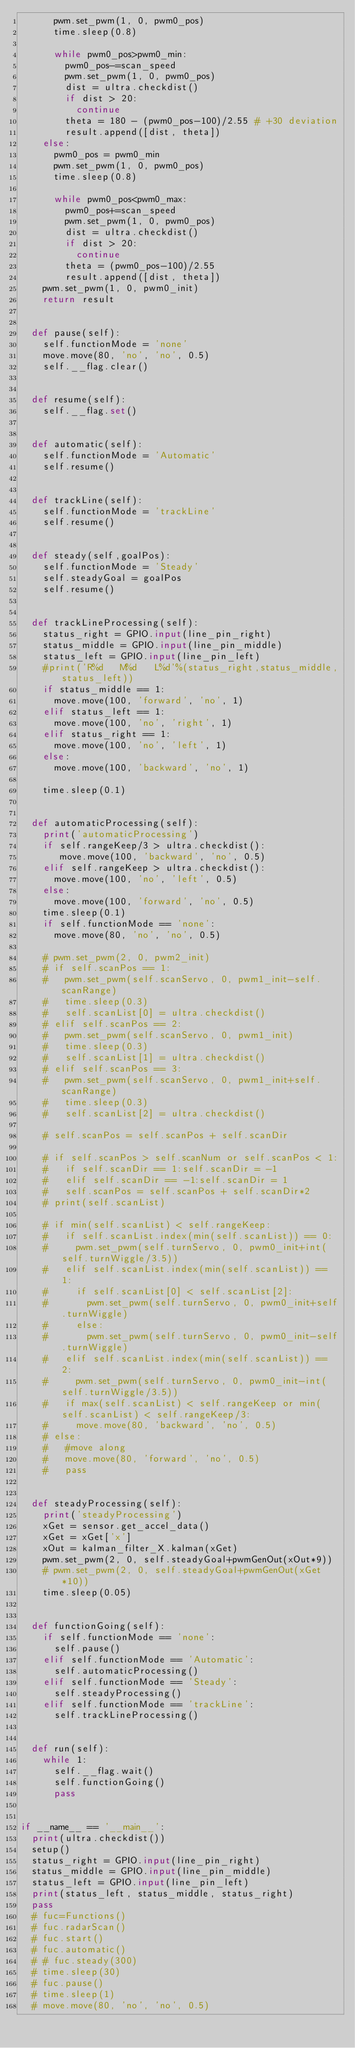<code> <loc_0><loc_0><loc_500><loc_500><_Python_>			pwm.set_pwm(1, 0, pwm0_pos)
			time.sleep(0.8)

			while pwm0_pos>pwm0_min:
				pwm0_pos-=scan_speed
				pwm.set_pwm(1, 0, pwm0_pos)
				dist = ultra.checkdist()
				if dist > 20:
					continue
				theta = 180 - (pwm0_pos-100)/2.55 # +30 deviation
				result.append([dist, theta])
		else:
			pwm0_pos = pwm0_min
			pwm.set_pwm(1, 0, pwm0_pos)
			time.sleep(0.8)

			while pwm0_pos<pwm0_max:
				pwm0_pos+=scan_speed
				pwm.set_pwm(1, 0, pwm0_pos)
				dist = ultra.checkdist()
				if dist > 20:
					continue
				theta = (pwm0_pos-100)/2.55
				result.append([dist, theta])
		pwm.set_pwm(1, 0, pwm0_init)
		return result


	def pause(self):
		self.functionMode = 'none'
		move.move(80, 'no', 'no', 0.5)
		self.__flag.clear()


	def resume(self):
		self.__flag.set()


	def automatic(self):
		self.functionMode = 'Automatic'
		self.resume()


	def trackLine(self):
		self.functionMode = 'trackLine'
		self.resume()


	def steady(self,goalPos):
		self.functionMode = 'Steady'
		self.steadyGoal = goalPos
		self.resume()


	def trackLineProcessing(self):
		status_right = GPIO.input(line_pin_right)
		status_middle = GPIO.input(line_pin_middle)
		status_left = GPIO.input(line_pin_left)
		#print('R%d   M%d   L%d'%(status_right,status_middle,status_left))
		if status_middle == 1:
			move.move(100, 'forward', 'no', 1)
		elif status_left == 1:
			move.move(100, 'no', 'right', 1)
		elif status_right == 1:
			move.move(100, 'no', 'left', 1)
		else:
			move.move(100, 'backward', 'no', 1)

		time.sleep(0.1)


	def automaticProcessing(self):
		print('automaticProcessing')
		if self.rangeKeep/3 > ultra.checkdist():
			 move.move(100, 'backward', 'no', 0.5)
		elif self.rangeKeep > ultra.checkdist():
			move.move(100, 'no', 'left', 0.5)
		else:
			move.move(100, 'forward', 'no', 0.5)
		time.sleep(0.1)
		if self.functionMode == 'none':
			move.move(80, 'no', 'no', 0.5)

		# pwm.set_pwm(2, 0, pwm2_init)
		# if self.scanPos == 1:
		# 	pwm.set_pwm(self.scanServo, 0, pwm1_init-self.scanRange)
		# 	time.sleep(0.3)
		# 	self.scanList[0] = ultra.checkdist()
		# elif self.scanPos == 2:
		# 	pwm.set_pwm(self.scanServo, 0, pwm1_init)
		# 	time.sleep(0.3)
		# 	self.scanList[1] = ultra.checkdist()
		# elif self.scanPos == 3:
		# 	pwm.set_pwm(self.scanServo, 0, pwm1_init+self.scanRange)
		# 	time.sleep(0.3)
		# 	self.scanList[2] = ultra.checkdist()

		# self.scanPos = self.scanPos + self.scanDir

		# if self.scanPos > self.scanNum or self.scanPos < 1:
		# 	if self.scanDir == 1:self.scanDir = -1
		# 	elif self.scanDir == -1:self.scanDir = 1
		# 	self.scanPos = self.scanPos + self.scanDir*2
		# print(self.scanList)

		# if min(self.scanList) < self.rangeKeep:
		# 	if self.scanList.index(min(self.scanList)) == 0:
		# 		pwm.set_pwm(self.turnServo, 0, pwm0_init+int(self.turnWiggle/3.5))
		# 	elif self.scanList.index(min(self.scanList)) == 1:
		# 		if self.scanList[0] < self.scanList[2]:
		# 			pwm.set_pwm(self.turnServo, 0, pwm0_init+self.turnWiggle)
		# 		else:
		# 			pwm.set_pwm(self.turnServo, 0, pwm0_init-self.turnWiggle)
		# 	elif self.scanList.index(min(self.scanList)) == 2:
		# 		pwm.set_pwm(self.turnServo, 0, pwm0_init-int(self.turnWiggle/3.5))
		# 	if max(self.scanList) < self.rangeKeep or min(self.scanList) < self.rangeKeep/3:
		# 		move.move(80, 'backward', 'no', 0.5)
		# else:
		# 	#move along
		# 	move.move(80, 'forward', 'no', 0.5)
		# 	pass


	def steadyProcessing(self):
		print('steadyProcessing')
		xGet = sensor.get_accel_data()
		xGet = xGet['x']
		xOut = kalman_filter_X.kalman(xGet)
		pwm.set_pwm(2, 0, self.steadyGoal+pwmGenOut(xOut*9))
		# pwm.set_pwm(2, 0, self.steadyGoal+pwmGenOut(xGet*10))
		time.sleep(0.05)


	def functionGoing(self):
		if self.functionMode == 'none':
			self.pause()
		elif self.functionMode == 'Automatic':
			self.automaticProcessing()
		elif self.functionMode == 'Steady':
			self.steadyProcessing()
		elif self.functionMode == 'trackLine':
			self.trackLineProcessing()


	def run(self):
		while 1:
			self.__flag.wait()
			self.functionGoing()
			pass


if __name__ == '__main__':
	print(ultra.checkdist())
	setup()
	status_right = GPIO.input(line_pin_right)
	status_middle = GPIO.input(line_pin_middle)
	status_left = GPIO.input(line_pin_left)
	print(status_left, status_middle, status_right)
	pass
	# fuc=Functions()
	# fuc.radarScan()
	# fuc.start()
	# fuc.automatic()
	# # fuc.steady(300)
	# time.sleep(30)
	# fuc.pause()
	# time.sleep(1)
	# move.move(80, 'no', 'no', 0.5)
</code> 